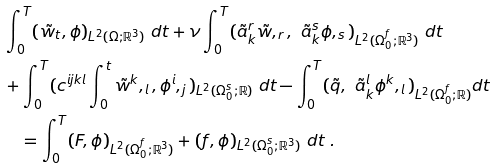Convert formula to latex. <formula><loc_0><loc_0><loc_500><loc_500>& \int _ { 0 } ^ { T } ( \tilde { w } _ { t } , \phi ) _ { L ^ { 2 } ( \Omega ; { \mathbb { R } } ^ { 3 } ) } \ d t + \nu \int _ { 0 } ^ { T } ( \tilde { a } _ { k } ^ { r } \tilde { w } , _ { r } , \ \tilde { a } _ { k } ^ { s } \phi , _ { s } ) _ { L ^ { 2 } ( \Omega _ { 0 } ^ { f } ; { \mathbb { R } } ^ { 3 } ) } \ d t \\ & + \int _ { 0 } ^ { T } ( c ^ { i j k l } \int _ { 0 } ^ { t } \tilde { w } ^ { k } , _ { l } , { \phi } ^ { i } , _ { j } ) _ { L ^ { 2 } ( \Omega _ { 0 } ^ { s } ; { \mathbb { R } } ) } \ d t - \int _ { 0 } ^ { T } ( \tilde { q } , \ \tilde { a } _ { k } ^ { l } \phi ^ { k } , _ { l } ) _ { L ^ { 2 } ( \Omega _ { 0 } ^ { f } ; { \mathbb { R } } ) } d t \\ & \quad = \int _ { 0 } ^ { T } ( F , \phi ) _ { L ^ { 2 } ( \Omega _ { 0 } ^ { f } ; { \mathbb { R } } ^ { 3 } ) } + ( f , \phi ) _ { L ^ { 2 } ( \Omega _ { 0 } ^ { s } ; { \mathbb { R } } ^ { 3 } ) } \ d t \ .</formula> 